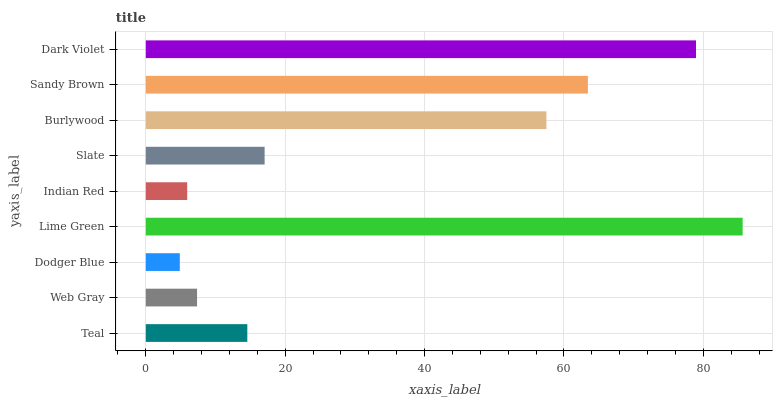Is Dodger Blue the minimum?
Answer yes or no. Yes. Is Lime Green the maximum?
Answer yes or no. Yes. Is Web Gray the minimum?
Answer yes or no. No. Is Web Gray the maximum?
Answer yes or no. No. Is Teal greater than Web Gray?
Answer yes or no. Yes. Is Web Gray less than Teal?
Answer yes or no. Yes. Is Web Gray greater than Teal?
Answer yes or no. No. Is Teal less than Web Gray?
Answer yes or no. No. Is Slate the high median?
Answer yes or no. Yes. Is Slate the low median?
Answer yes or no. Yes. Is Burlywood the high median?
Answer yes or no. No. Is Sandy Brown the low median?
Answer yes or no. No. 